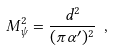Convert formula to latex. <formula><loc_0><loc_0><loc_500><loc_500>M _ { \psi } ^ { 2 } = { \frac { d ^ { 2 } } { ( \pi \alpha ^ { \prime } ) ^ { 2 } } } \ ,</formula> 